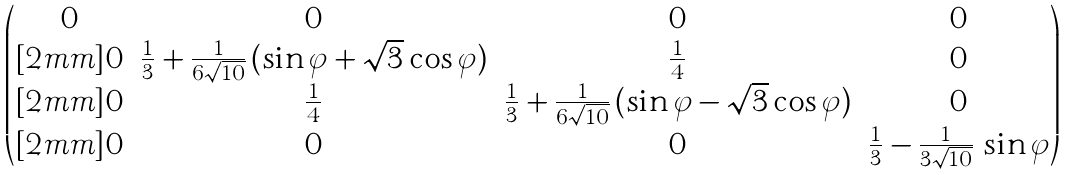Convert formula to latex. <formula><loc_0><loc_0><loc_500><loc_500>\begin{pmatrix} 0 & 0 & 0 & 0 \\ [ 2 m m ] 0 & \frac { 1 } { 3 } + \frac { 1 } { 6 \sqrt { 1 0 } } \, ( \sin \varphi + \sqrt { 3 } \cos \varphi ) & \frac { 1 } { 4 } & 0 \\ [ 2 m m ] 0 & \frac { 1 } { 4 } & \frac { 1 } { 3 } + \frac { 1 } { 6 \sqrt { 1 0 } } \, ( \sin \varphi - \sqrt { 3 } \cos \varphi ) & 0 \\ [ 2 m m ] 0 & 0 & 0 & \frac { 1 } { 3 } - \frac { 1 } { 3 \sqrt { 1 0 } } \, \sin \varphi \end{pmatrix}</formula> 